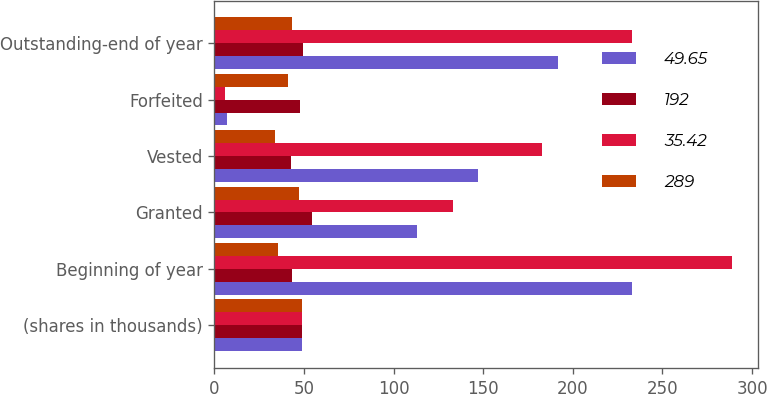Convert chart. <chart><loc_0><loc_0><loc_500><loc_500><stacked_bar_chart><ecel><fcel>(shares in thousands)<fcel>Beginning of year<fcel>Granted<fcel>Vested<fcel>Forfeited<fcel>Outstanding-end of year<nl><fcel>49.65<fcel>48.765<fcel>233<fcel>113<fcel>147<fcel>7<fcel>192<nl><fcel>192<fcel>48.765<fcel>43.23<fcel>54.3<fcel>42.82<fcel>47.88<fcel>49.65<nl><fcel>35.42<fcel>48.765<fcel>289<fcel>133<fcel>183<fcel>6<fcel>233<nl><fcel>289<fcel>48.765<fcel>35.42<fcel>47.4<fcel>34.04<fcel>40.91<fcel>43.23<nl></chart> 